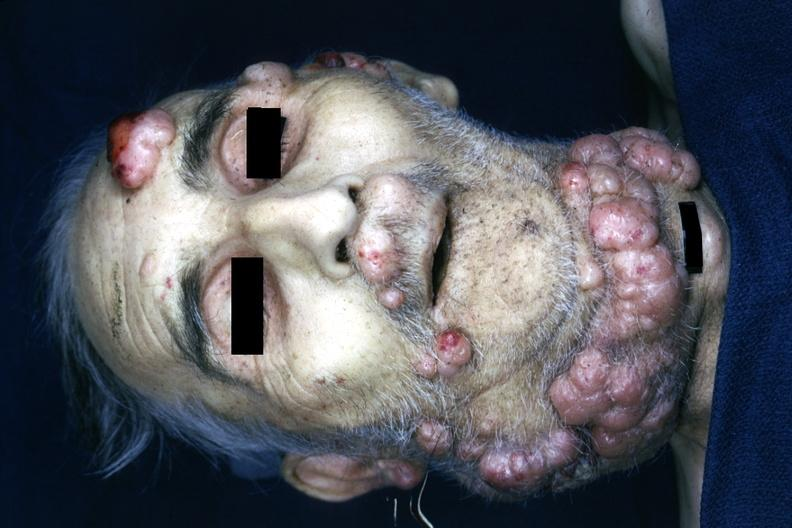what is present?
Answer the question using a single word or phrase. Disease 